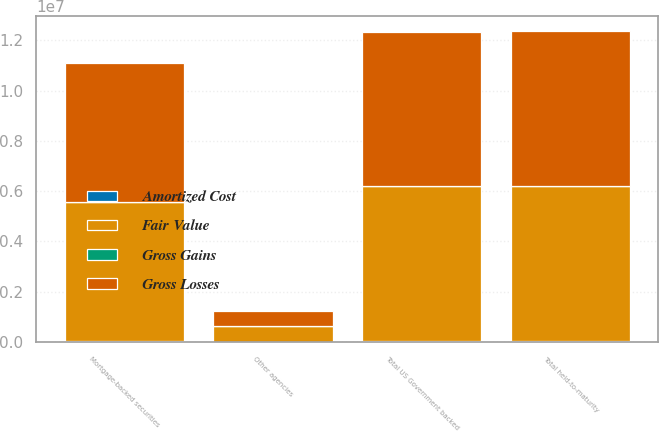<chart> <loc_0><loc_0><loc_500><loc_500><stacked_bar_chart><ecel><fcel>Mortgage-backed securities<fcel>Other agencies<fcel>Total US Government backed<fcel>Total held-to-maturity<nl><fcel>Fair Value<fcel>5.5325e+06<fcel>620052<fcel>6.15255e+06<fcel>6.15959e+06<nl><fcel>Gross Gains<fcel>14637<fcel>1645<fcel>16282<fcel>16282<nl><fcel>Amortized Cost<fcel>37504<fcel>2786<fcel>40290<fcel>40414<nl><fcel>Gross Losses<fcel>5.50963e+06<fcel>618911<fcel>6.12854e+06<fcel>6.13546e+06<nl></chart> 